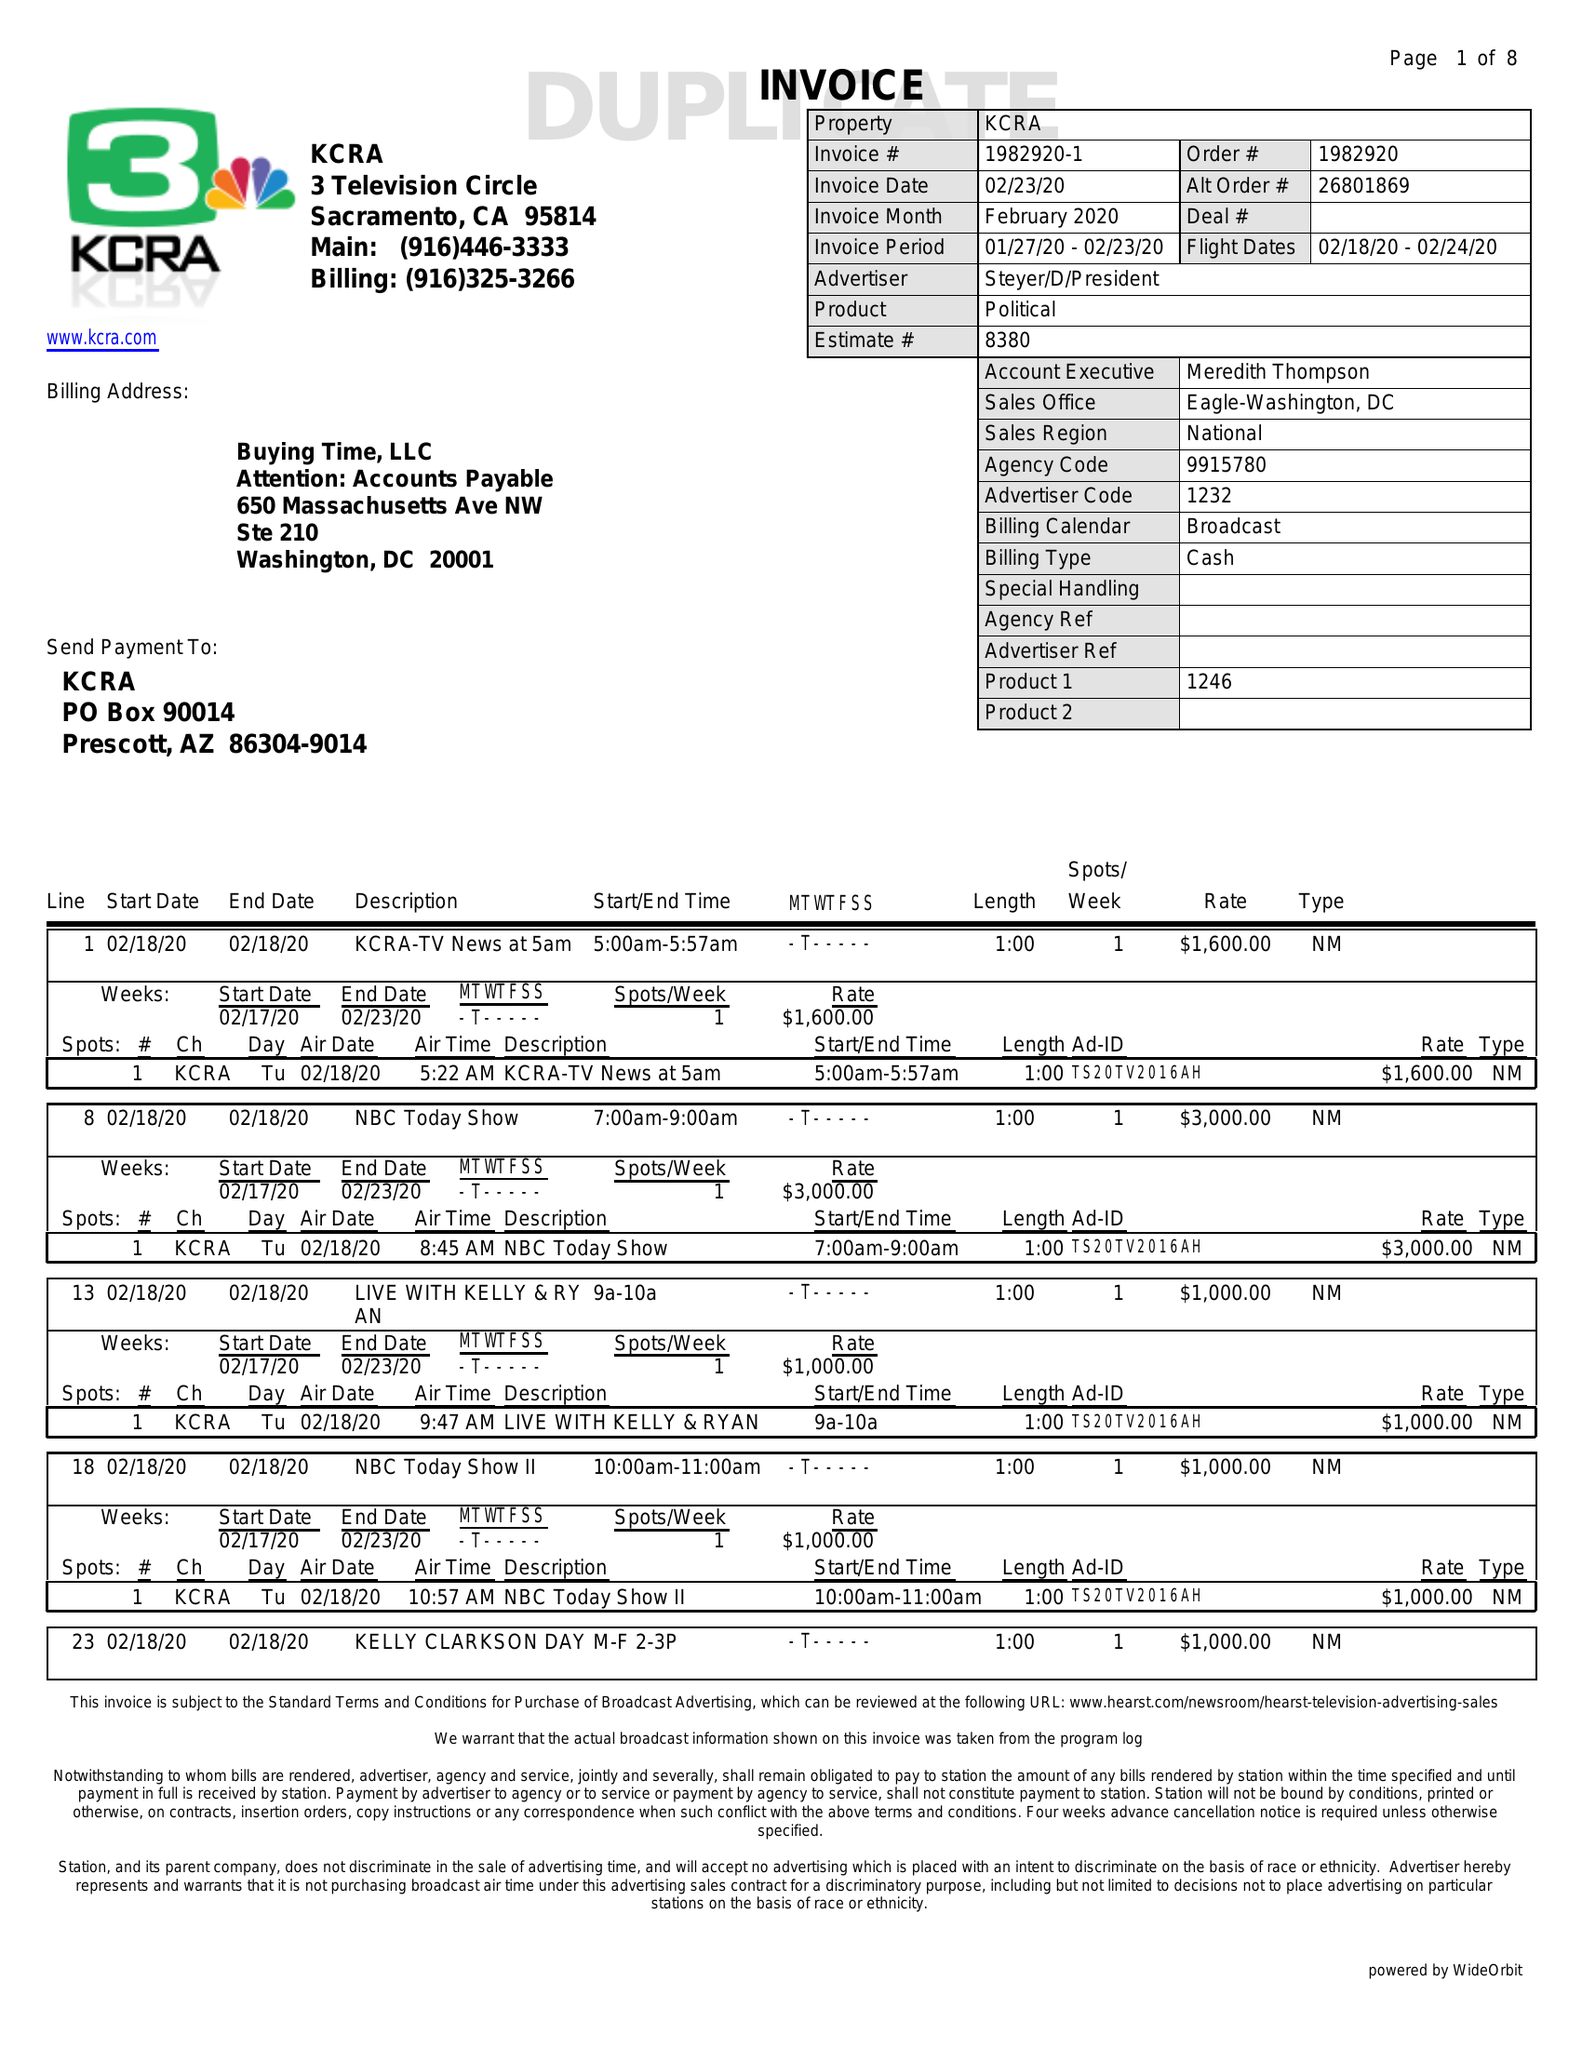What is the value for the flight_to?
Answer the question using a single word or phrase. 02/24/20 